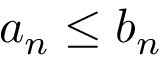Convert formula to latex. <formula><loc_0><loc_0><loc_500><loc_500>a _ { n } \leq b _ { n }</formula> 